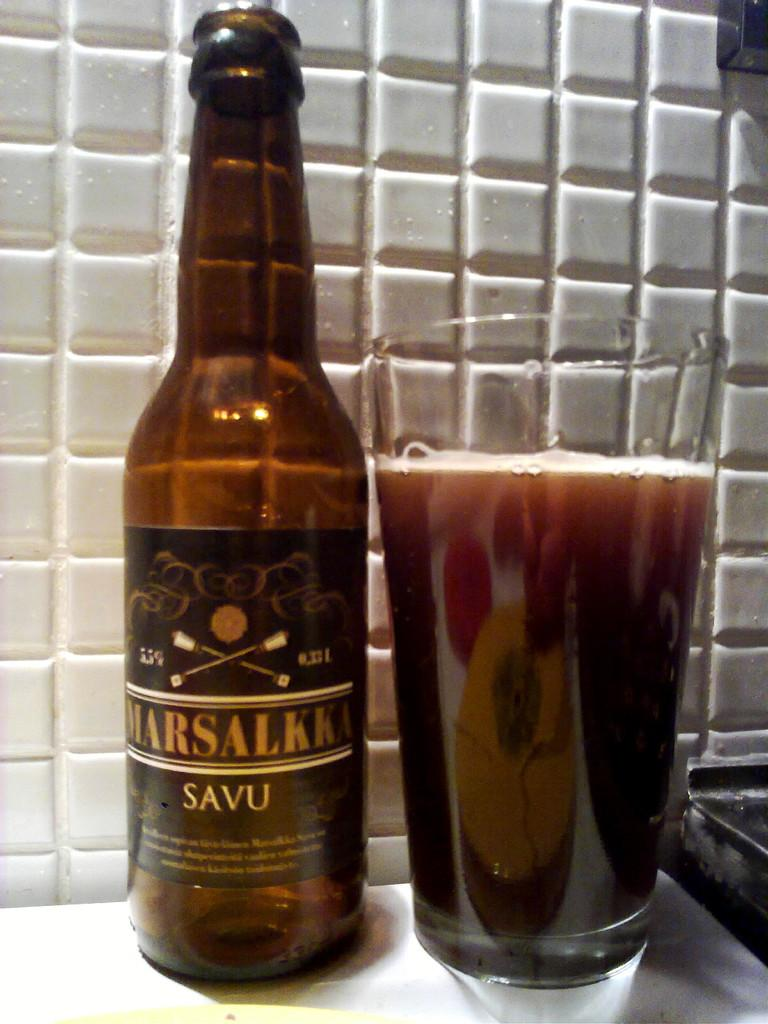<image>
Relay a brief, clear account of the picture shown. A bottle of Marsalkka beer next to a pint glass of it. 